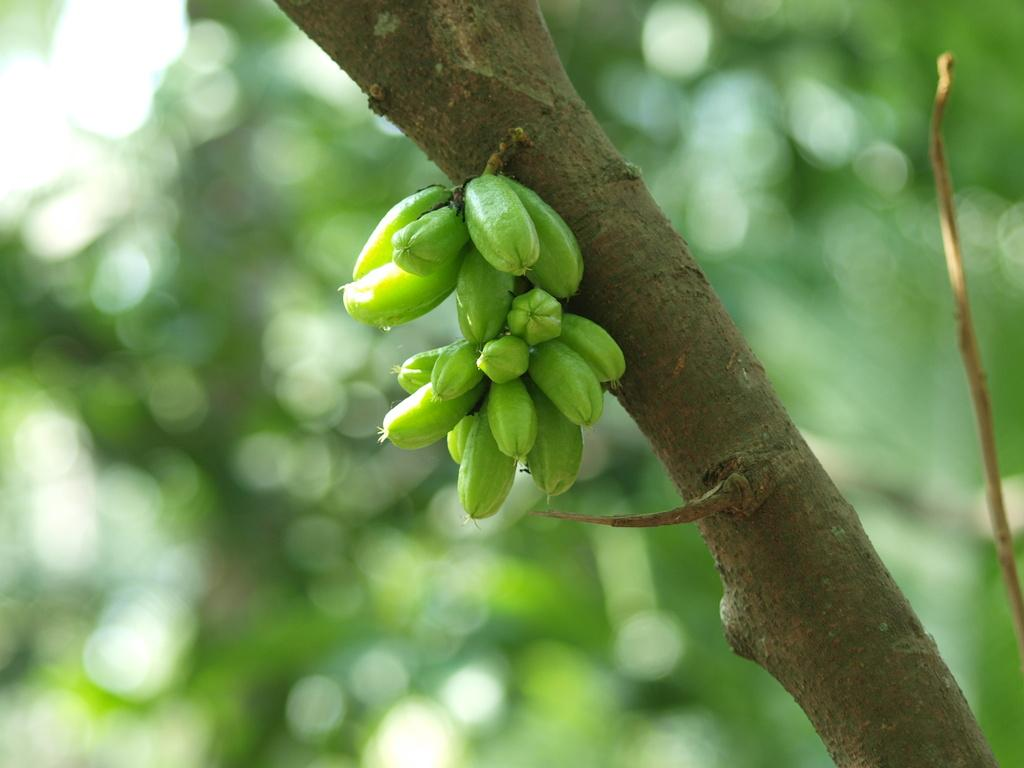What is present in the image? There is a plant in the image. What can be observed about the plant's fruits? The plant has green color fruits. What can be seen in the background of the image? There are trees in the background of the image. How would you describe the background's appearance? The background is blurred. How much dust is visible on the wire in the image? There is no wire present in the image, so it is not possible to determine the amount of dust on it. 